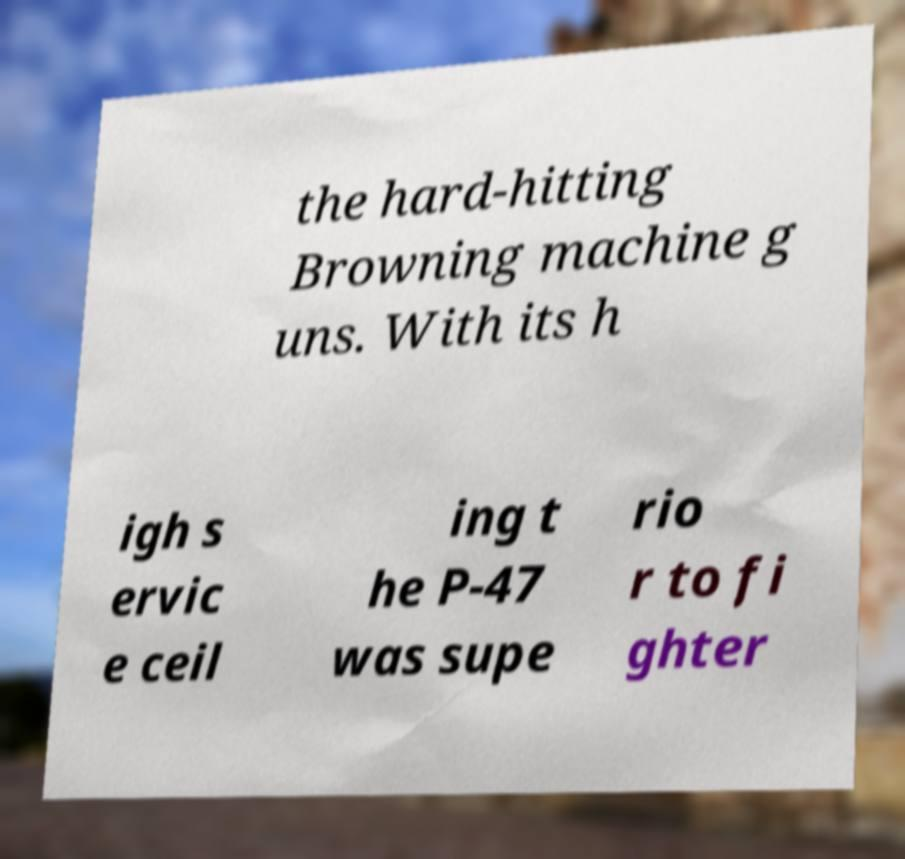Could you assist in decoding the text presented in this image and type it out clearly? the hard-hitting Browning machine g uns. With its h igh s ervic e ceil ing t he P-47 was supe rio r to fi ghter 